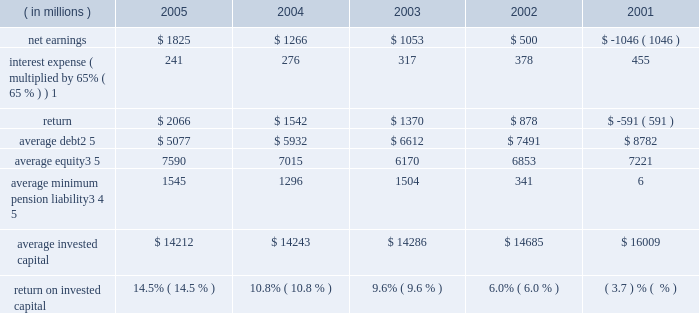Page 74 notes to five year summary ( a ) includes the effects of items not considered in senior management 2019s assessment of the operating performance of the corporation 2019s business segments ( see the section , 201cresults of operations 201d in management 2019s discussion and analysis of financial condition and results of operations ( md&a ) ) which , on a combined basis , increased earnings from continuing operations before income taxes by $ 173 million , $ 113 million after tax ( $ 0.25 per share ) .
( b ) includes the effects of items not considered in senior management 2019s assessment of the operating performance of the corporation 2019s business segments ( see the section , 201cresults of operations 201d in md&a ) which , on a combined basis , decreased earnings from continuing operations before income taxes by $ 215 million , $ 154 million after tax ( $ 0.34 per share ) .
Also includes a reduction in income tax expense resulting from the closure of an internal revenue service examination of $ 144 million ( $ 0.32 per share ) .
These items reduced earnings by $ 10 million after tax ( $ 0.02 per share ) .
( c ) includes the effects of items not considered in senior management 2019s assessment of the operating performance of the corporation 2019s business segments ( see the section , 201cresults of operations 201d in md&a ) which , on a combined basis , decreased earnings from continuing operations before income taxes by $ 153 million , $ 102 million after tax ( $ 0.22 per share ) .
( d ) includes the effects of items not considered in senior management 2019s assessment of the operating performance of the corporation 2019s business segments which , on a combined basis , decreased earnings from continuing operations before income taxes by $ 1112 million , $ 632 million after tax ( $ 1.40 per share ) .
In 2002 , the corporation adopted fas 142 which prohibits the amortization of goodwill .
( e ) includes the effects of items not considered in senior management 2019s assessment of the operating performance of the corporation 2019s business segments which , on a combined basis , decreased earnings from continuing operations before income taxes by $ 973 million , $ 651 million after tax ( $ 1.50 per share ) .
Also includes a gain from the disposal of a business and charges for the corporation 2019s exit from its global telecommunications services business which is included in discontinued operations and which , on a combined basis , increased the net loss by $ 1 billion ( $ 2.38 per share ) .
( f ) the corporation defines return on invested capital ( roic ) as net income plus after-tax interest expense divided by average invested capital ( stockholders 2019 equity plus debt ) , after adjusting stockholders 2019 equity by adding back the minimum pension liability .
The adjustment to add back the minimum pension liability is a revision to our calculation in 2005 , which the corporation believes more closely links roic to management performance .
Further , the corporation believes that reporting roic provides investors with greater visibility into how effectively lockheed martin uses the capital invested in its operations .
The corporation uses roic to evaluate multi-year investment decisions and as a long-term performance measure , and also uses roic as a factor in evaluating management performance under certain incentive compensation plans .
Roic is not a measure of financial performance under gaap , and may not be defined and calculated by other companies in the same manner .
Roic should not be considered in isola- tion or as an alternative to net earnings as an indicator of performance .
The following calculations of roic reflect the revision to the calculation discussed above for all periods presented .
( in millions ) 2005 2004 2003 2002 2001 .
1 represents after-tax interest expense utilizing the federal statutory rate of 35% ( 35 % ) .
2 debt consists of long-term debt , including current maturities , and short-term borrowings ( if any ) .
3 equity includes non-cash adjustments for other comprehensive losses , primarily for the additional minimum pension liability .
4 minimum pension liability values reflect the cumulative value of entries identified in our statement of stockholders equity under the caption 201cminimum pension liability . 201d the annual minimum pension liability adjustments to equity were : 2001 = ( $ 33 million ) ; 2002 = ( $ 1537 million ) ; 2003 = $ 331 million ; 2004 = ( $ 285 million ) ; 2005 = ( $ 105 million ) .
As these entries are recorded in the fourth quarter , the value added back to our average equity in a given year is the cumulative impact of all prior year entries plus 20% ( 20 % ) of the cur- rent year entry value .
5 yearly averages are calculated using balances at the start of the year and at the end of each quarter .
Lockheed martin corporation .
What was the percent of the change in the net earnings from 2004 to 2005? 
Computations: ((1825 - 1266) / 1266)
Answer: 0.44155. 